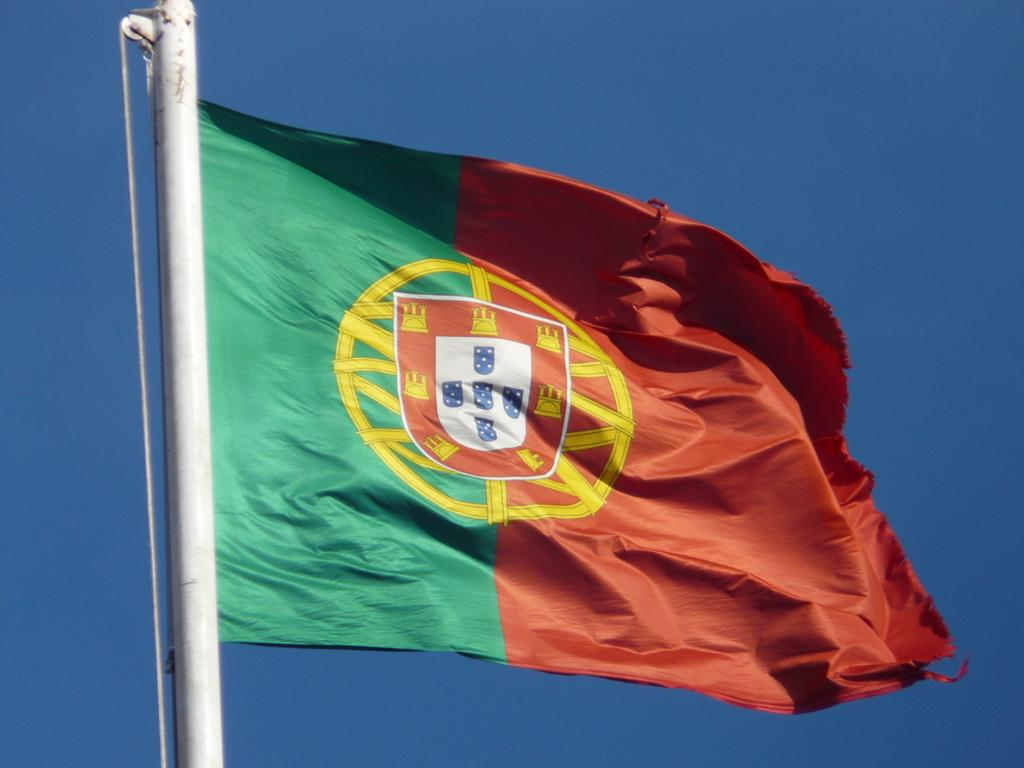What colors are present on the flag in the image? The flag in the image has green and red colors. What can be seen in the background of the image? There is a sky visible in the image. What is the weight of the nut used to hold the flag in place? There is no nut present in the image, and therefore no weight can be determined. 